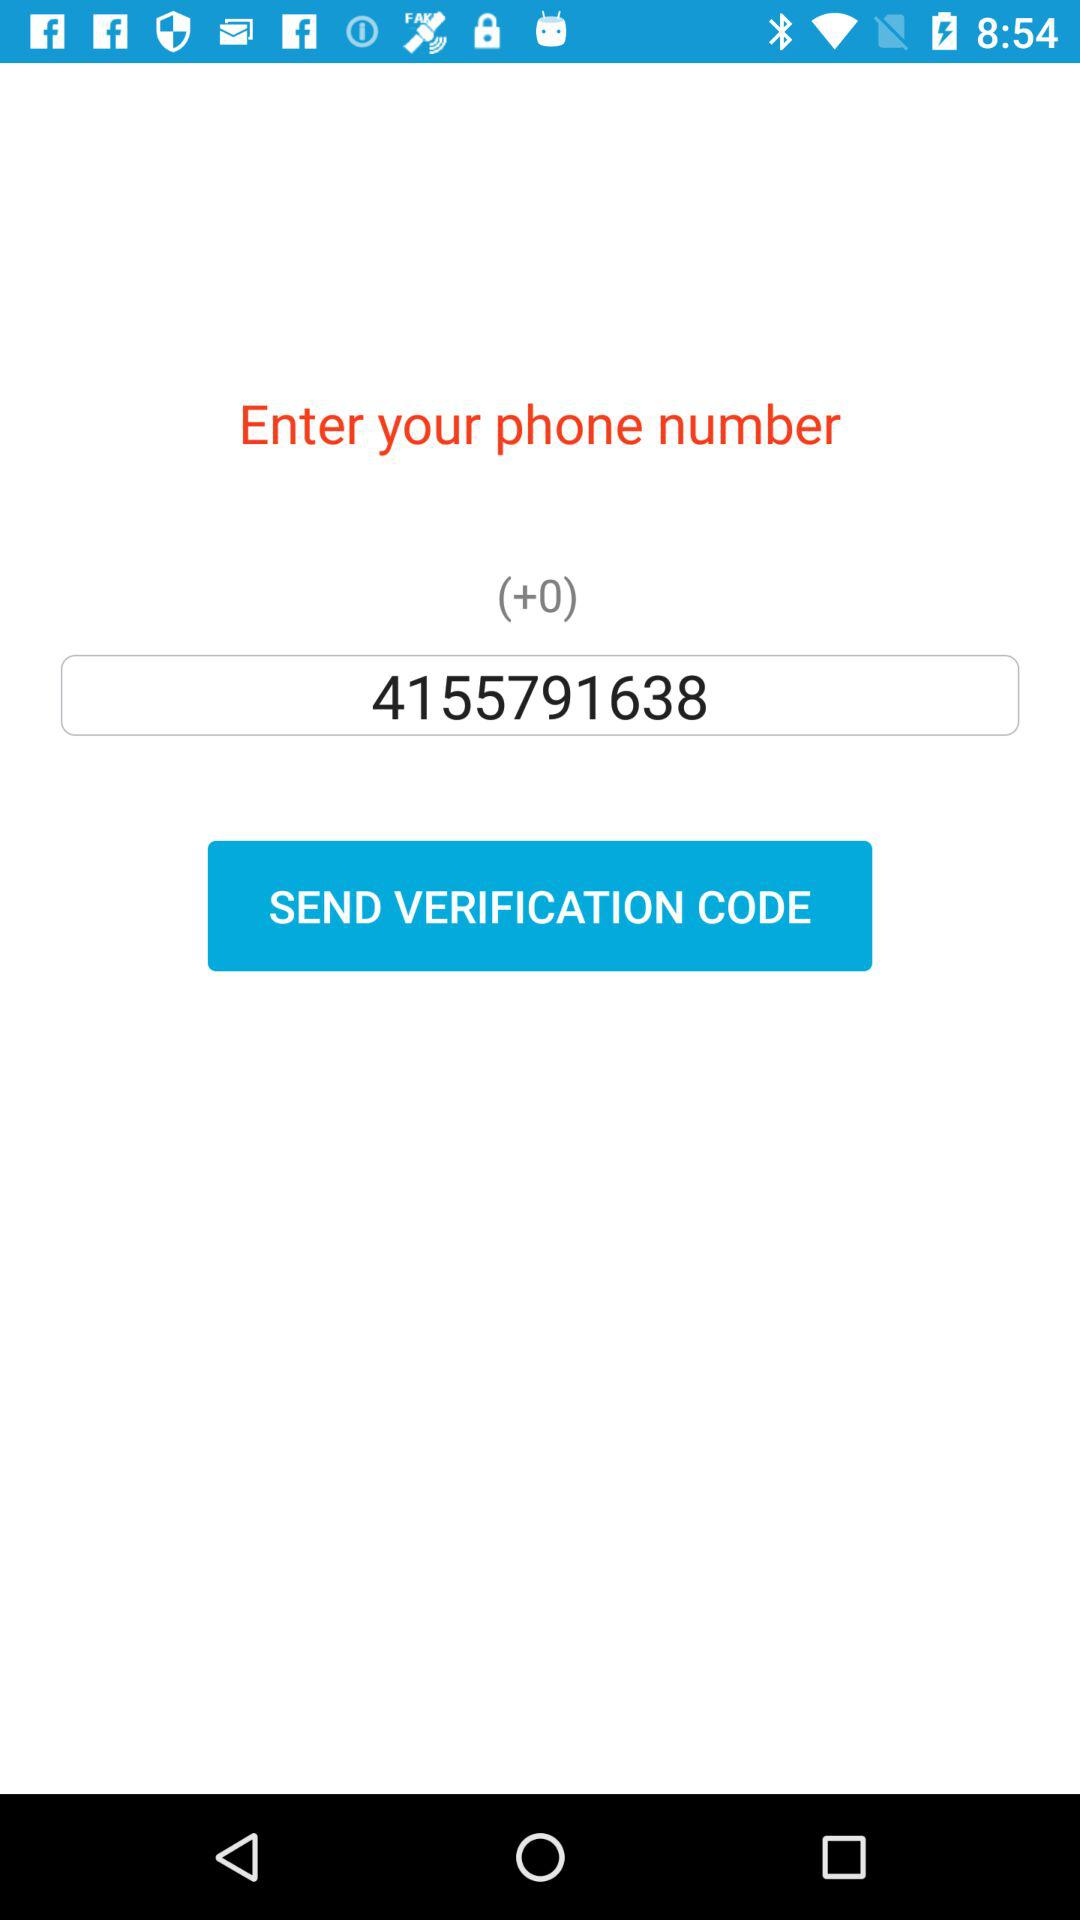What is the code used with the phone number? The code is +0. 